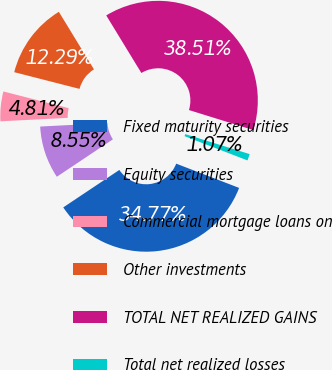Convert chart to OTSL. <chart><loc_0><loc_0><loc_500><loc_500><pie_chart><fcel>Fixed maturity securities<fcel>Equity securities<fcel>Commercial mortgage loans on<fcel>Other investments<fcel>TOTAL NET REALIZED GAINS<fcel>Total net realized losses<nl><fcel>34.77%<fcel>8.55%<fcel>4.81%<fcel>12.29%<fcel>38.51%<fcel>1.07%<nl></chart> 